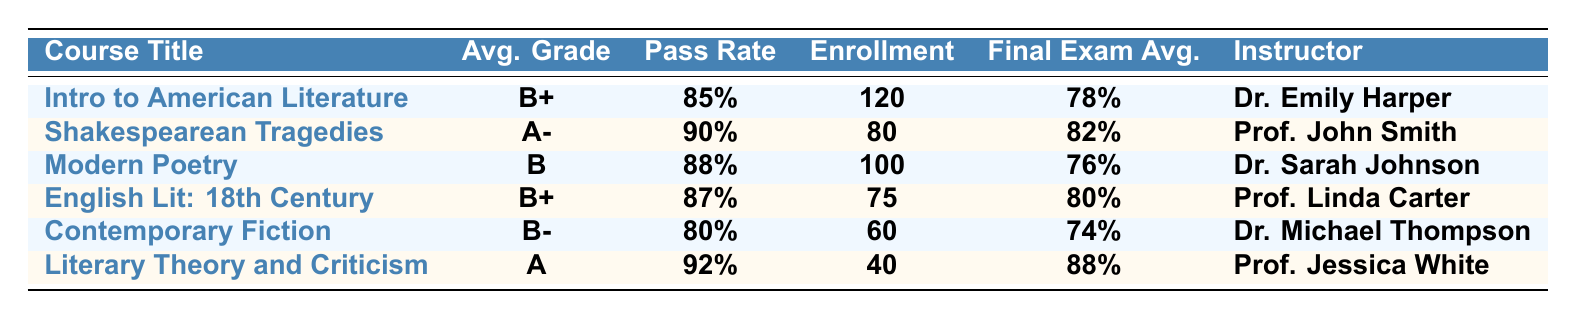What is the average grade in "Literary Theory and Criticism"? The table shows that the average grade in "Literary Theory and Criticism" is "A".
Answer: A Which course has the highest pass rate? By examining the pass rates, "Literary Theory and Criticism" has the highest pass rate at 92%.
Answer: 92% What is the enrollment count for "Contemporary Fiction"? Looking at the table, the enrollment count for "Contemporary Fiction" is 60 students.
Answer: 60 What is the final exam average for "Modern Poetry"? The final exam average for "Modern Poetry" is reported as 76% in the table.
Answer: 76% Is the average grade for "Shakespearean Tragedies" higher than that for "English Literature: 18th Century"? The average grade for "Shakespearean Tragedies" is A- (higher) compared to B+ for "English Literature: 18th Century".
Answer: Yes How many courses have an average grade of B or lower? There are three courses with an average grade of B or lower: "Modern Poetry" (B), "Contemporary Fiction" (B-), with a total of 3 courses fulfilling this condition.
Answer: 3 Calculate the average final exam average across all courses. Adding the final exam averages: 78% + 82% + 76% + 80% + 74% + 88% = 478%. Dividing by 6 gives 478%/6 = 79.67%.
Answer: 79.67% What percentage of students passed the "Literary Theory and Criticism" course? The pass rate for "Literary Theory and Criticism" is 92%, directly indicating that 92% of students passed.
Answer: 92% Which instructor has the lowest pass rate among the listed courses? Dr. Michael Thompson's course, "Contemporary Fiction," has the lowest pass rate of 80%.
Answer: Dr. Michael Thompson If we consider the average grades, which course performed better: "Modern Poetry" or "Contemporary Fiction"? "Modern Poetry" has a B average while "Contemporary Fiction" has a B-. Therefore, "Modern Poetry" performed better.
Answer: Modern Poetry 